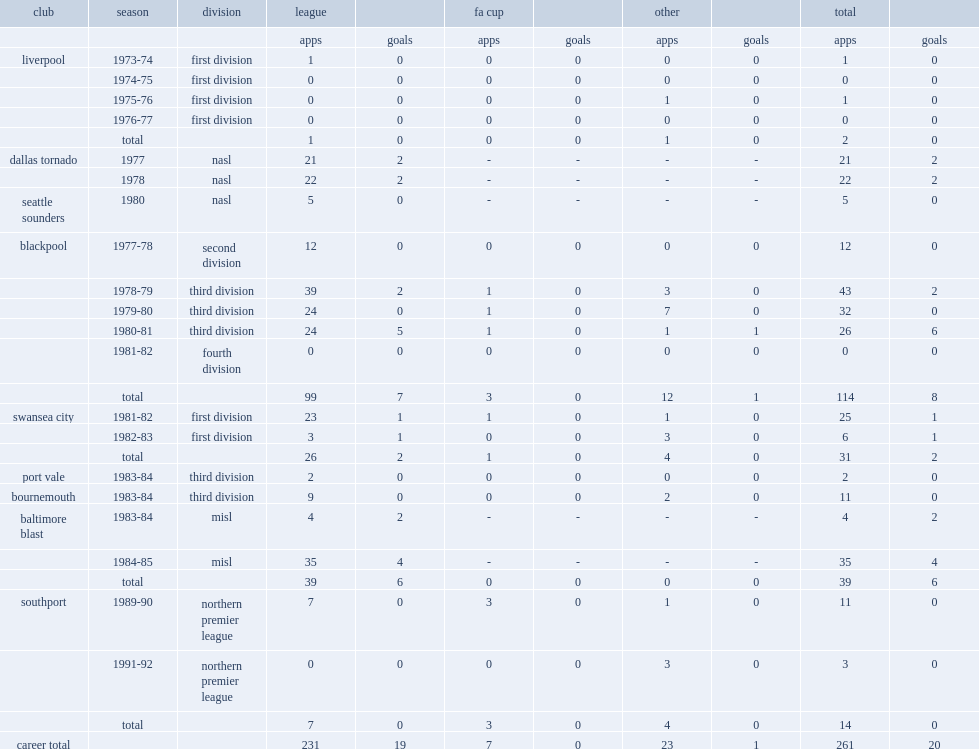Which league did thompson start his career with liverpool during the 1973-74 season? First division. 